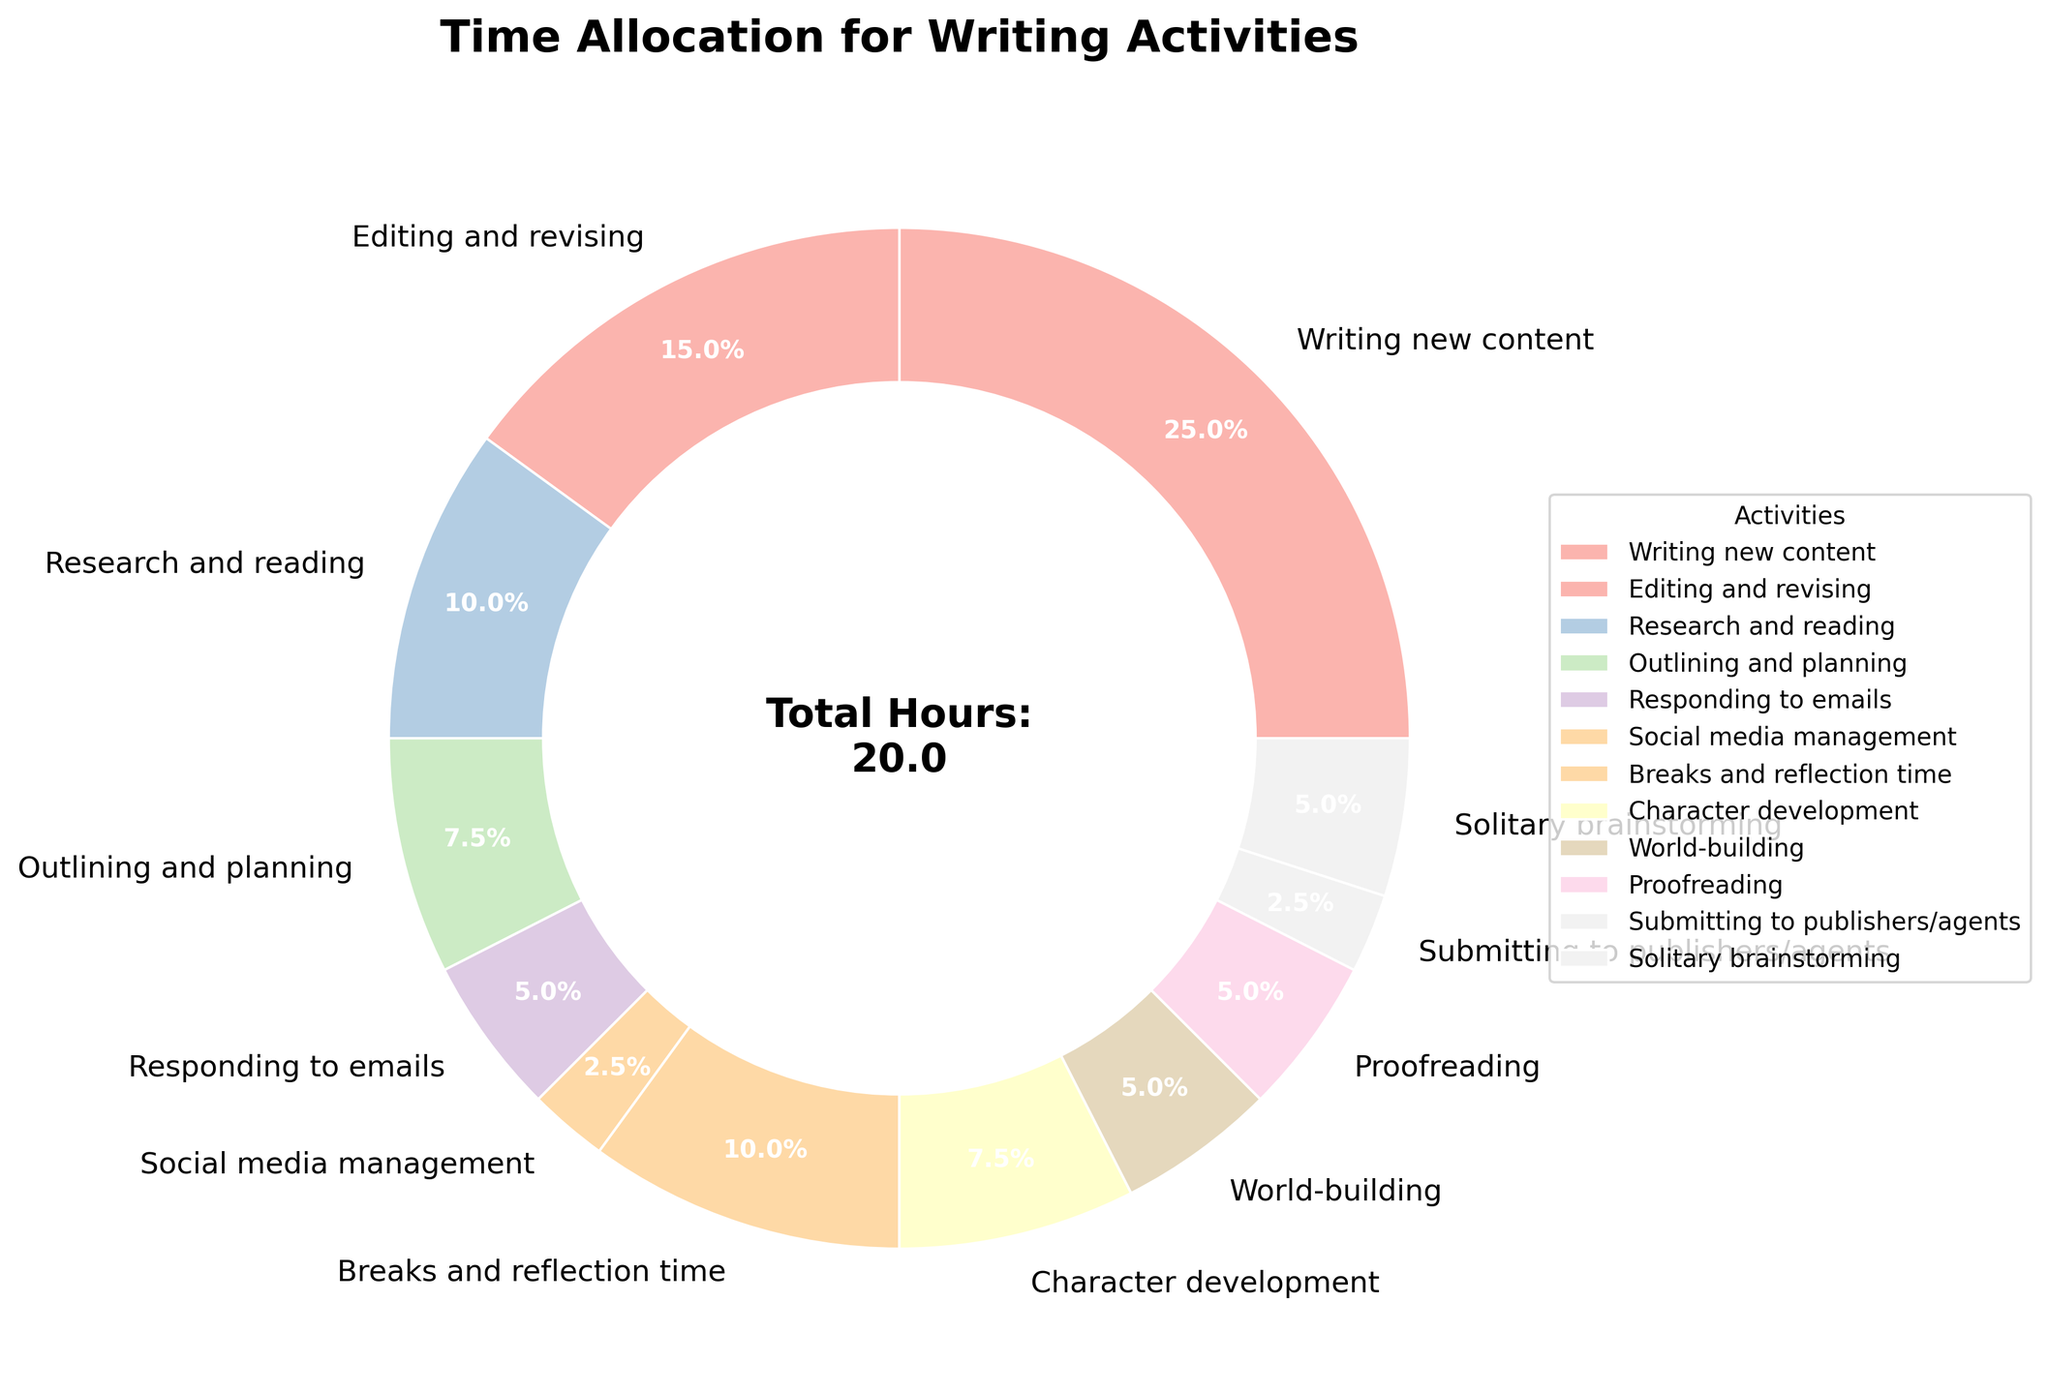Which activity takes up the largest portion of the writer's day? By examining the wedges of the pie chart and looking at the percentage labels, "Writing new content" has the largest portion.
Answer: Writing new content How many hours are spent on proofreading and responding to emails combined? The pie chart shows 1 hour for proofreading and 1 hour for responding to emails. Summing these gives 1 + 1 = 2 hours.
Answer: 2 hours What is the difference in time spent on editing and revising compared to writing new content? The pie chart indicates 5 hours for writing new content and 3 hours for editing and revising. The difference is 5 - 3 = 2 hours.
Answer: 2 hours Is more time spent on research and reading or on breaks and reflection time? Research and reading accounts for 2 hours, while breaks and reflection time accounts for 2 hours. Since 2 = 2, they are equal.
Answer: Equal What percentage of the day is spent on solitary brainstorming? By looking at the wedge labeled "Solitary brainstorming" in the pie chart, it shows that this activity takes 1 hour out of the total. To find the percentage: (1/20) * 100 = 5%.
Answer: 5% What is the total time allocated to character development and world-building? The pie chart shows 1.5 hours for character development and 1 hour for world-building. Summing these gives 1.5 + 1 = 2.5 hours.
Answer: 2.5 hours If we combine the time spent on outlining and planning with the time spent on social media management, how many hours is that in total? The pie chart indicates 1.5 hours for outlining and planning and 0.5 hours for social media management. Summing these gives 1.5 + 0.5 = 2 hours.
Answer: 2 hours Which activity between submitting to publishers/agents and world-building takes up less time? The pie chart shows that submitting to publishers/agents takes 0.5 hours, while world-building takes 1 hour. Since 0.5 < 1, submitting to publishers/agents takes up less time.
Answer: Submitting to publishers/agents What's the sum of hours spent on activities that take less than an hour individually? The activities that take less than an hour are social media management (0.5) and submitting to publishers/agents (0.5). Summing these gives 0.5 + 0.5 = 1 hour.
Answer: 1 hour Considering only the time spent on breaks and reflection time and editing and revising, which one is longer? The pie chart shows that breaks and reflection time take up 2 hours, while editing and revising take up 3 hours. Since 3 > 2, editing and revising takes up more time.
Answer: Editing and revising 